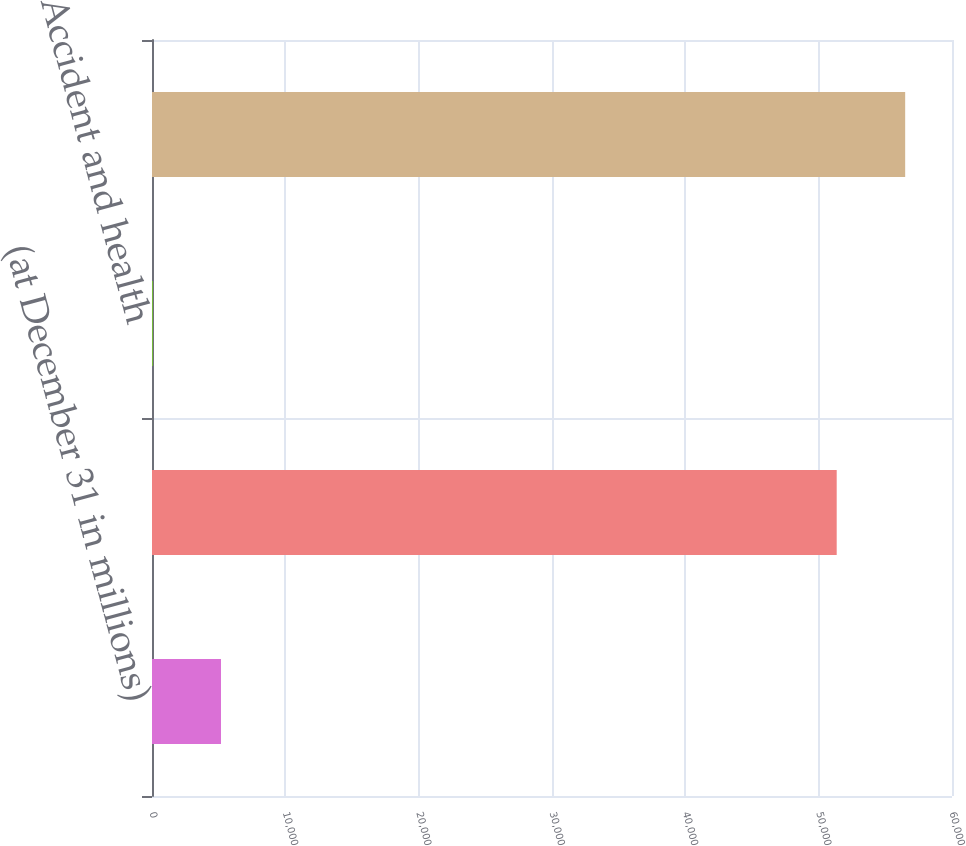Convert chart. <chart><loc_0><loc_0><loc_500><loc_500><bar_chart><fcel>(at December 31 in millions)<fcel>Property-casualty<fcel>Accident and health<fcel>Total<nl><fcel>5174.3<fcel>51353<fcel>39<fcel>56488.3<nl></chart> 